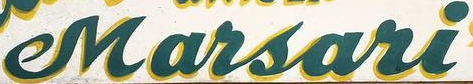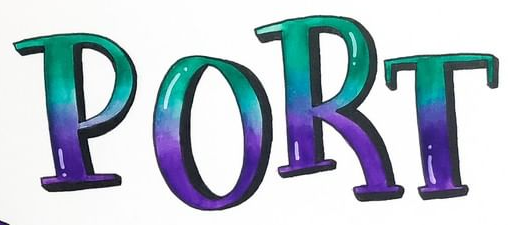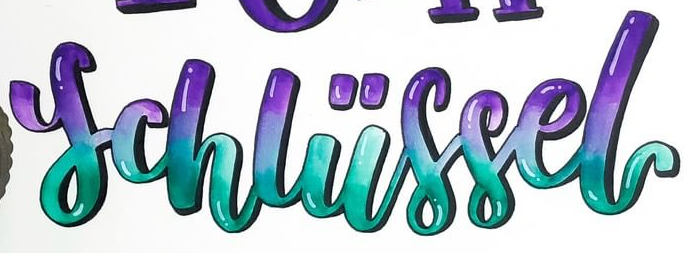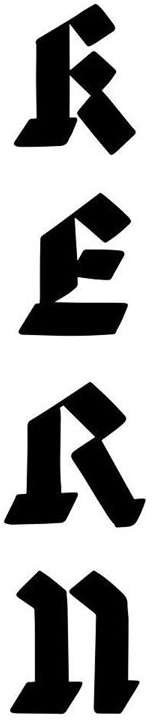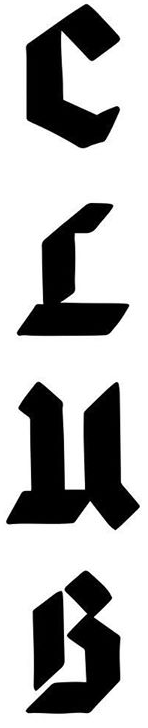What words are shown in these images in order, separated by a semicolon? Marsari; PORT; schliissel; RERn; CLuB 